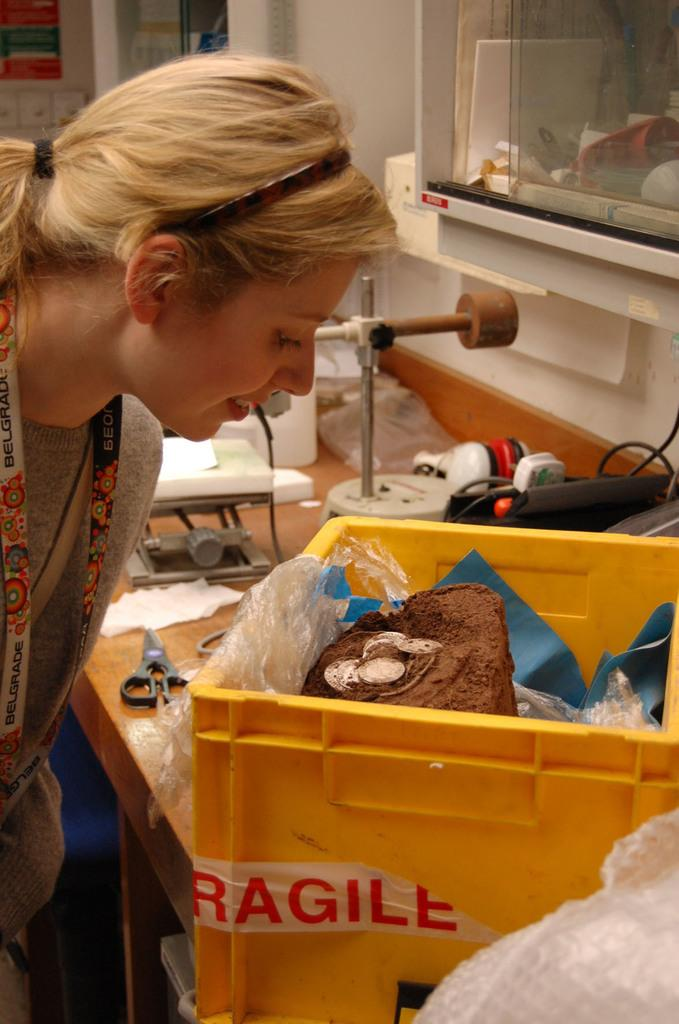<image>
Give a short and clear explanation of the subsequent image. The box shown that the woman is looking into must contain fragile stuff. 